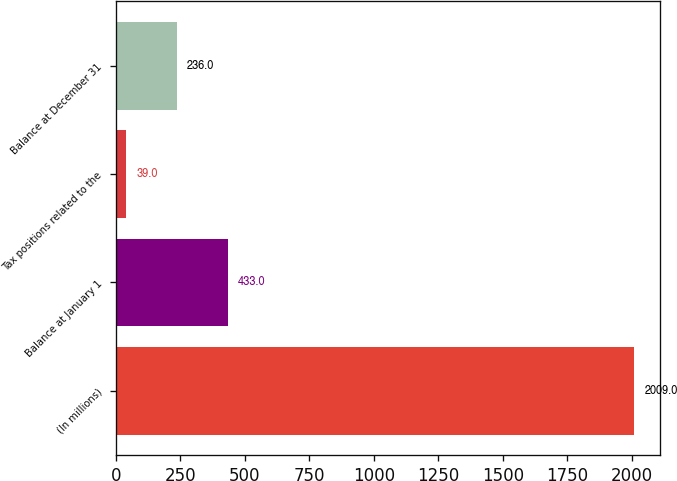Convert chart. <chart><loc_0><loc_0><loc_500><loc_500><bar_chart><fcel>(In millions)<fcel>Balance at January 1<fcel>Tax positions related to the<fcel>Balance at December 31<nl><fcel>2009<fcel>433<fcel>39<fcel>236<nl></chart> 